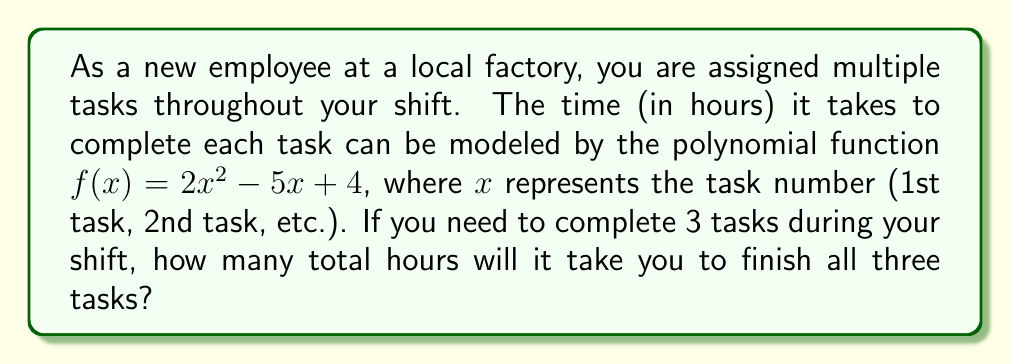Give your solution to this math problem. Let's approach this step-by-step:

1) We need to calculate the time for each of the three tasks and then sum them up.

2) For the first task ($x = 1$):
   $f(1) = 2(1)^2 - 5(1) + 4 = 2 - 5 + 4 = 1$ hour

3) For the second task ($x = 2$):
   $f(2) = 2(2)^2 - 5(2) + 4 = 8 - 10 + 4 = 2$ hours

4) For the third task ($x = 3$):
   $f(3) = 2(3)^2 - 5(3) + 4 = 18 - 15 + 4 = 7$ hours

5) Now, we sum up the time for all three tasks:
   Total time $= f(1) + f(2) + f(3) = 1 + 2 + 7 = 10$ hours

Therefore, it will take you a total of 10 hours to complete all three tasks.
Answer: 10 hours 